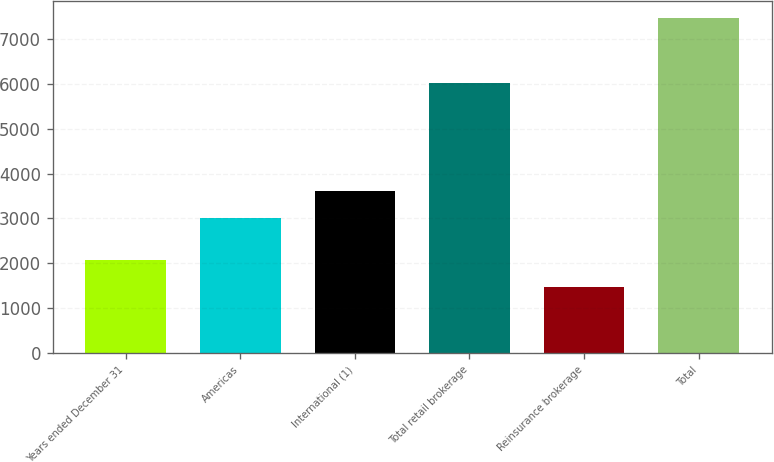Convert chart. <chart><loc_0><loc_0><loc_500><loc_500><bar_chart><fcel>Years ended December 31<fcel>Americas<fcel>International (1)<fcel>Total retail brokerage<fcel>Reinsurance brokerage<fcel>Total<nl><fcel>2065.2<fcel>3001<fcel>3603.2<fcel>6022<fcel>1463<fcel>7485<nl></chart> 